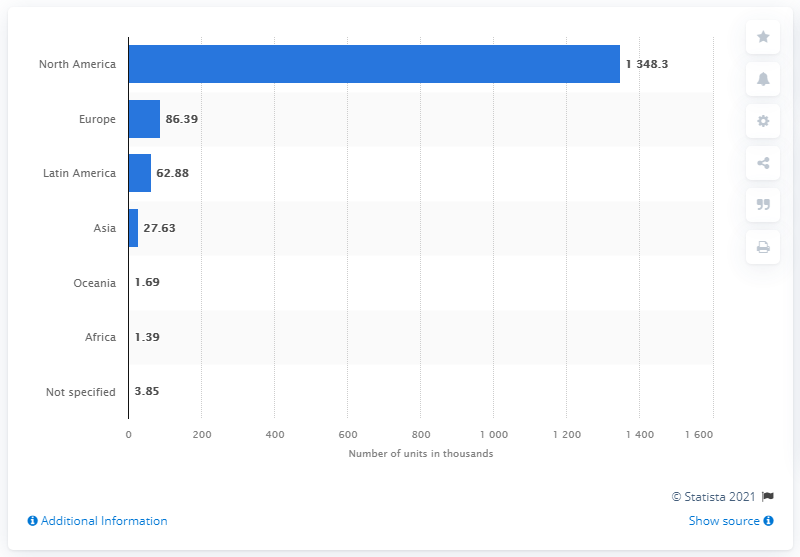Give some essential details in this illustration. In 2020, the region that was the primary destination for light vehicle exports from Mexico was North America. 